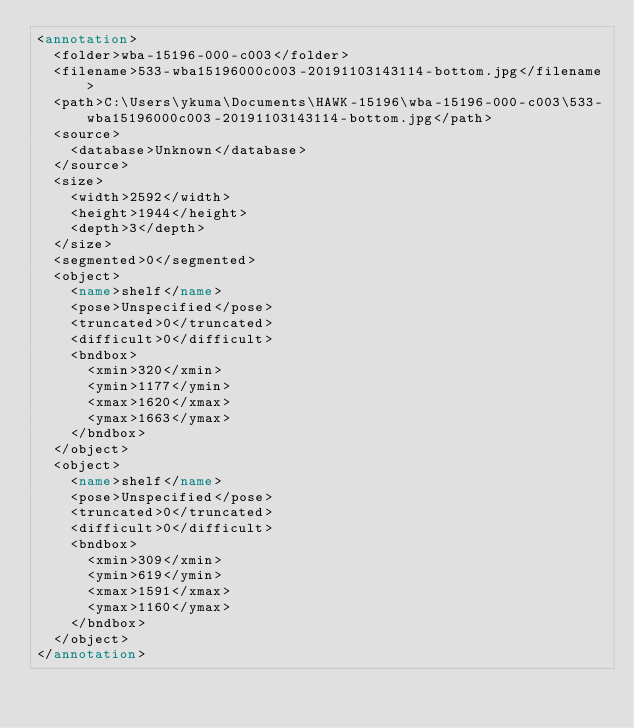Convert code to text. <code><loc_0><loc_0><loc_500><loc_500><_XML_><annotation>
	<folder>wba-15196-000-c003</folder>
	<filename>533-wba15196000c003-20191103143114-bottom.jpg</filename>
	<path>C:\Users\ykuma\Documents\HAWK-15196\wba-15196-000-c003\533-wba15196000c003-20191103143114-bottom.jpg</path>
	<source>
		<database>Unknown</database>
	</source>
	<size>
		<width>2592</width>
		<height>1944</height>
		<depth>3</depth>
	</size>
	<segmented>0</segmented>
	<object>
		<name>shelf</name>
		<pose>Unspecified</pose>
		<truncated>0</truncated>
		<difficult>0</difficult>
		<bndbox>
			<xmin>320</xmin>
			<ymin>1177</ymin>
			<xmax>1620</xmax>
			<ymax>1663</ymax>
		</bndbox>
	</object>
	<object>
		<name>shelf</name>
		<pose>Unspecified</pose>
		<truncated>0</truncated>
		<difficult>0</difficult>
		<bndbox>
			<xmin>309</xmin>
			<ymin>619</ymin>
			<xmax>1591</xmax>
			<ymax>1160</ymax>
		</bndbox>
	</object>
</annotation>
</code> 